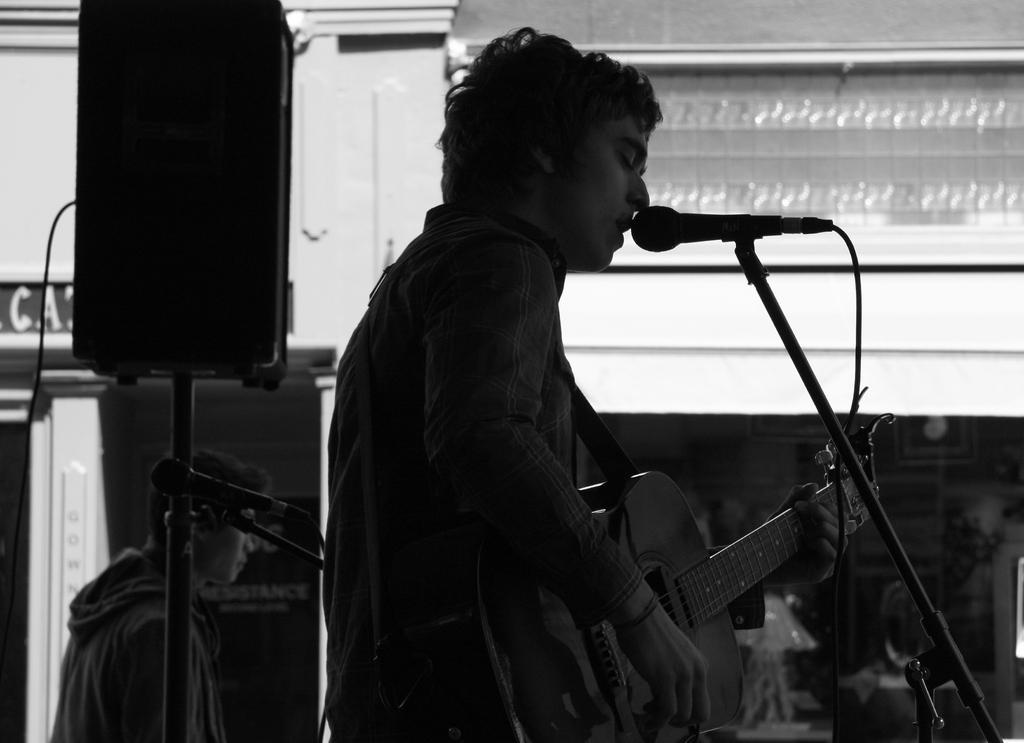Describe this image in one or two sentences. In this image,few peoples are there. The man is in the center. He is playing a guitar and he is singing in-front of mic. Here we can see stand, wire. And left side, the other man is there. There is a speaker in this position. At the background, white color wall and pillars and banner. 